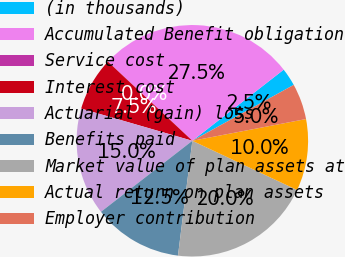Convert chart to OTSL. <chart><loc_0><loc_0><loc_500><loc_500><pie_chart><fcel>(in thousands)<fcel>Accumulated Benefit obligation<fcel>Service cost<fcel>Interest cost<fcel>Actuarial (gain) loss<fcel>Benefits paid<fcel>Market value of plan assets at<fcel>Actual return on plan assets<fcel>Employer contribution<nl><fcel>2.51%<fcel>27.48%<fcel>0.01%<fcel>7.5%<fcel>15.0%<fcel>12.5%<fcel>19.99%<fcel>10.0%<fcel>5.01%<nl></chart> 